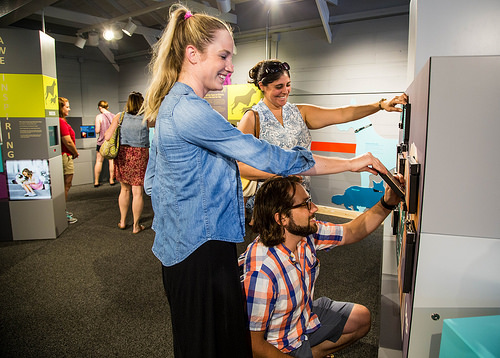<image>
Can you confirm if the woman is in front of the man? Yes. The woman is positioned in front of the man, appearing closer to the camera viewpoint. 